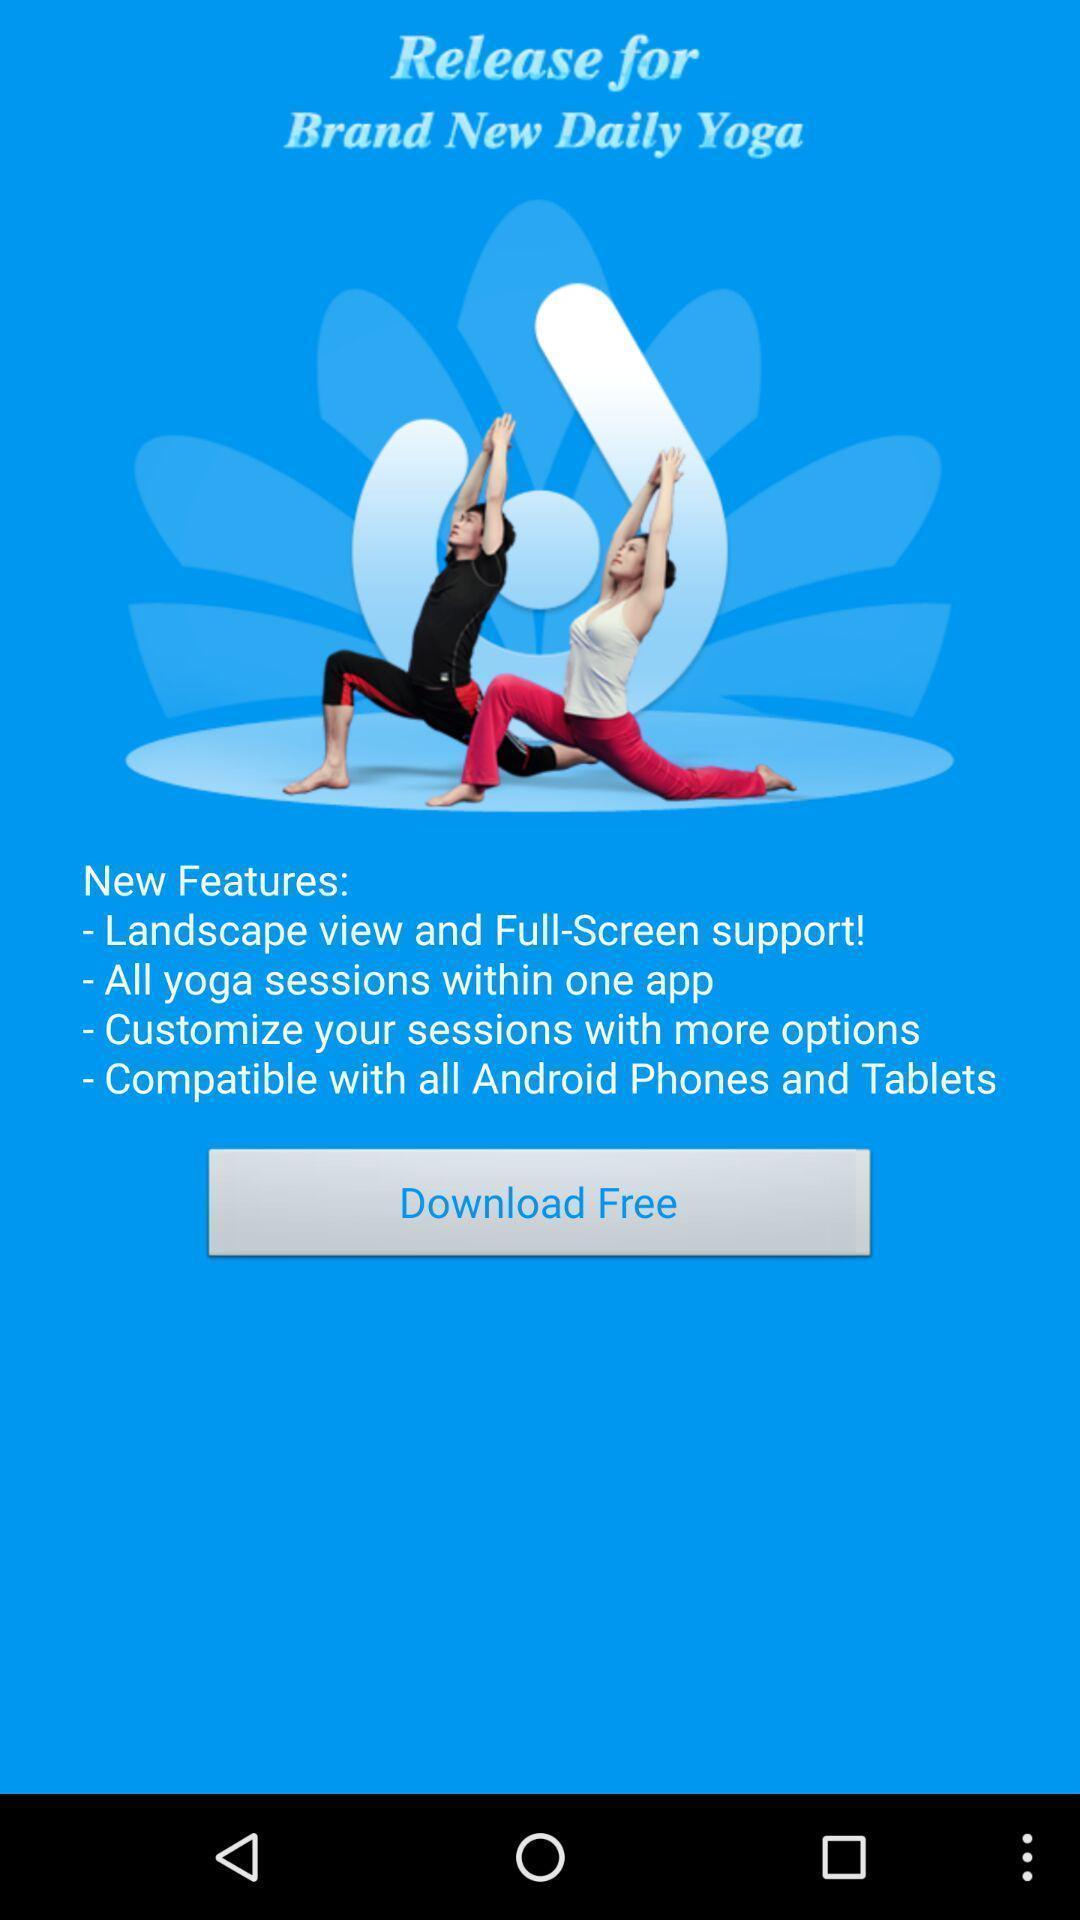Explain what's happening in this screen capture. Page displays to download app for free. 